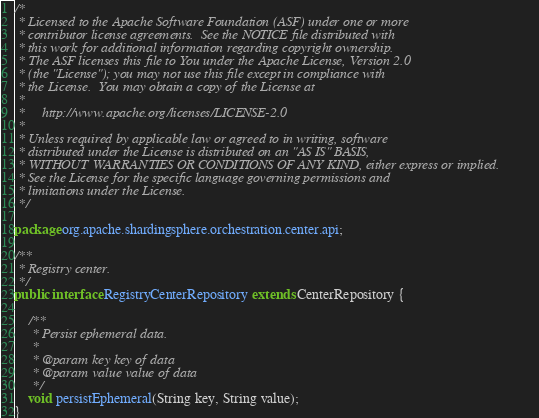<code> <loc_0><loc_0><loc_500><loc_500><_Java_>/*
 * Licensed to the Apache Software Foundation (ASF) under one or more
 * contributor license agreements.  See the NOTICE file distributed with
 * this work for additional information regarding copyright ownership.
 * The ASF licenses this file to You under the Apache License, Version 2.0
 * (the "License"); you may not use this file except in compliance with
 * the License.  You may obtain a copy of the License at
 *
 *     http://www.apache.org/licenses/LICENSE-2.0
 *
 * Unless required by applicable law or agreed to in writing, software
 * distributed under the License is distributed on an "AS IS" BASIS,
 * WITHOUT WARRANTIES OR CONDITIONS OF ANY KIND, either express or implied.
 * See the License for the specific language governing permissions and
 * limitations under the License.
 */

package org.apache.shardingsphere.orchestration.center.api;

/**
 * Registry center.
 */
public interface RegistryCenterRepository extends CenterRepository {
    
    /**
     * Persist ephemeral data.
     *
     * @param key key of data
     * @param value value of data
     */
    void persistEphemeral(String key, String value);
}
</code> 